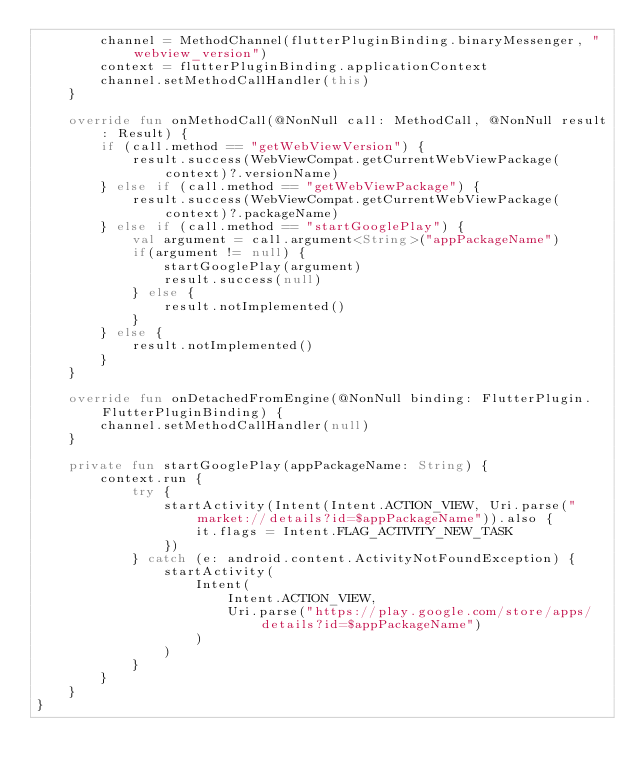<code> <loc_0><loc_0><loc_500><loc_500><_Kotlin_>        channel = MethodChannel(flutterPluginBinding.binaryMessenger, "webview_version")
        context = flutterPluginBinding.applicationContext
        channel.setMethodCallHandler(this)
    }

    override fun onMethodCall(@NonNull call: MethodCall, @NonNull result: Result) {
        if (call.method == "getWebViewVersion") {
            result.success(WebViewCompat.getCurrentWebViewPackage(context)?.versionName)
        } else if (call.method == "getWebViewPackage") {
            result.success(WebViewCompat.getCurrentWebViewPackage(context)?.packageName)
        } else if (call.method == "startGooglePlay") {
            val argument = call.argument<String>("appPackageName")
            if(argument != null) {
                startGooglePlay(argument)
                result.success(null)
            } else {
                result.notImplemented()
            }
        } else {
            result.notImplemented()
        }
    }

    override fun onDetachedFromEngine(@NonNull binding: FlutterPlugin.FlutterPluginBinding) {
        channel.setMethodCallHandler(null)
    }

    private fun startGooglePlay(appPackageName: String) {
        context.run {
            try {
                startActivity(Intent(Intent.ACTION_VIEW, Uri.parse("market://details?id=$appPackageName")).also {
                    it.flags = Intent.FLAG_ACTIVITY_NEW_TASK
                })
            } catch (e: android.content.ActivityNotFoundException) {
                startActivity(
                    Intent(
                        Intent.ACTION_VIEW,
                        Uri.parse("https://play.google.com/store/apps/details?id=$appPackageName")
                    )
                )
            }
        }
    }
}
</code> 